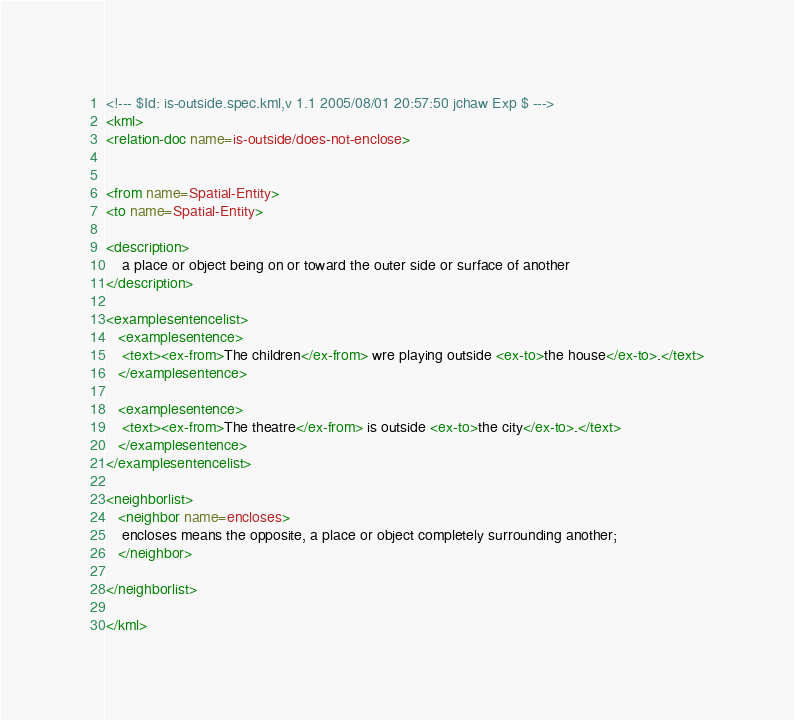Convert code to text. <code><loc_0><loc_0><loc_500><loc_500><_XML_><!--- $Id: is-outside.spec.kml,v 1.1 2005/08/01 20:57:50 jchaw Exp $ --->
<kml>
<relation-doc name=is-outside/does-not-enclose>


<from name=Spatial-Entity>
<to name=Spatial-Entity>

<description>
	a place or object being on or toward the outer side or surface of another
</description>

<examplesentencelist>
   <examplesentence>
	<text><ex-from>The children</ex-from> wre playing outside <ex-to>the house</ex-to>.</text>
   </examplesentence>

   <examplesentence>
	<text><ex-from>The theatre</ex-from> is outside <ex-to>the city</ex-to>.</text>
   </examplesentence>
</examplesentencelist>

<neighborlist>
   <neighbor name=encloses>
	encloses means the opposite, a place or object completely surrounding another;
   </neighbor>

</neighborlist>

</kml>
</code> 